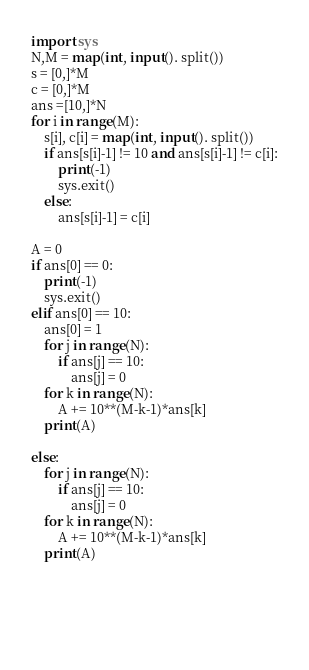<code> <loc_0><loc_0><loc_500><loc_500><_Python_>import sys
N,M = map(int, input(). split())
s = [0,]*M
c = [0,]*M
ans =[10,]*N
for i in range(M):
    s[i], c[i] = map(int, input(). split())
    if ans[s[i]-1] != 10 and ans[s[i]-1] != c[i]:
        print(-1)
        sys.exit()
    else:
        ans[s[i]-1] = c[i]
       
A = 0        
if ans[0] == 0:
    print(-1)
    sys.exit()
elif ans[0] == 10:
    ans[0] = 1
    for j in range(N):
        if ans[j] == 10:
            ans[j] = 0
    for k in range(N):
        A += 10**(M-k-1)*ans[k] 
    print(A)
        
else:
    for j in range(N):
        if ans[j] == 10:
            ans[j] = 0
    for k in range(N):
        A += 10**(M-k-1)*ans[k] 
    print(A)
    
    


    </code> 